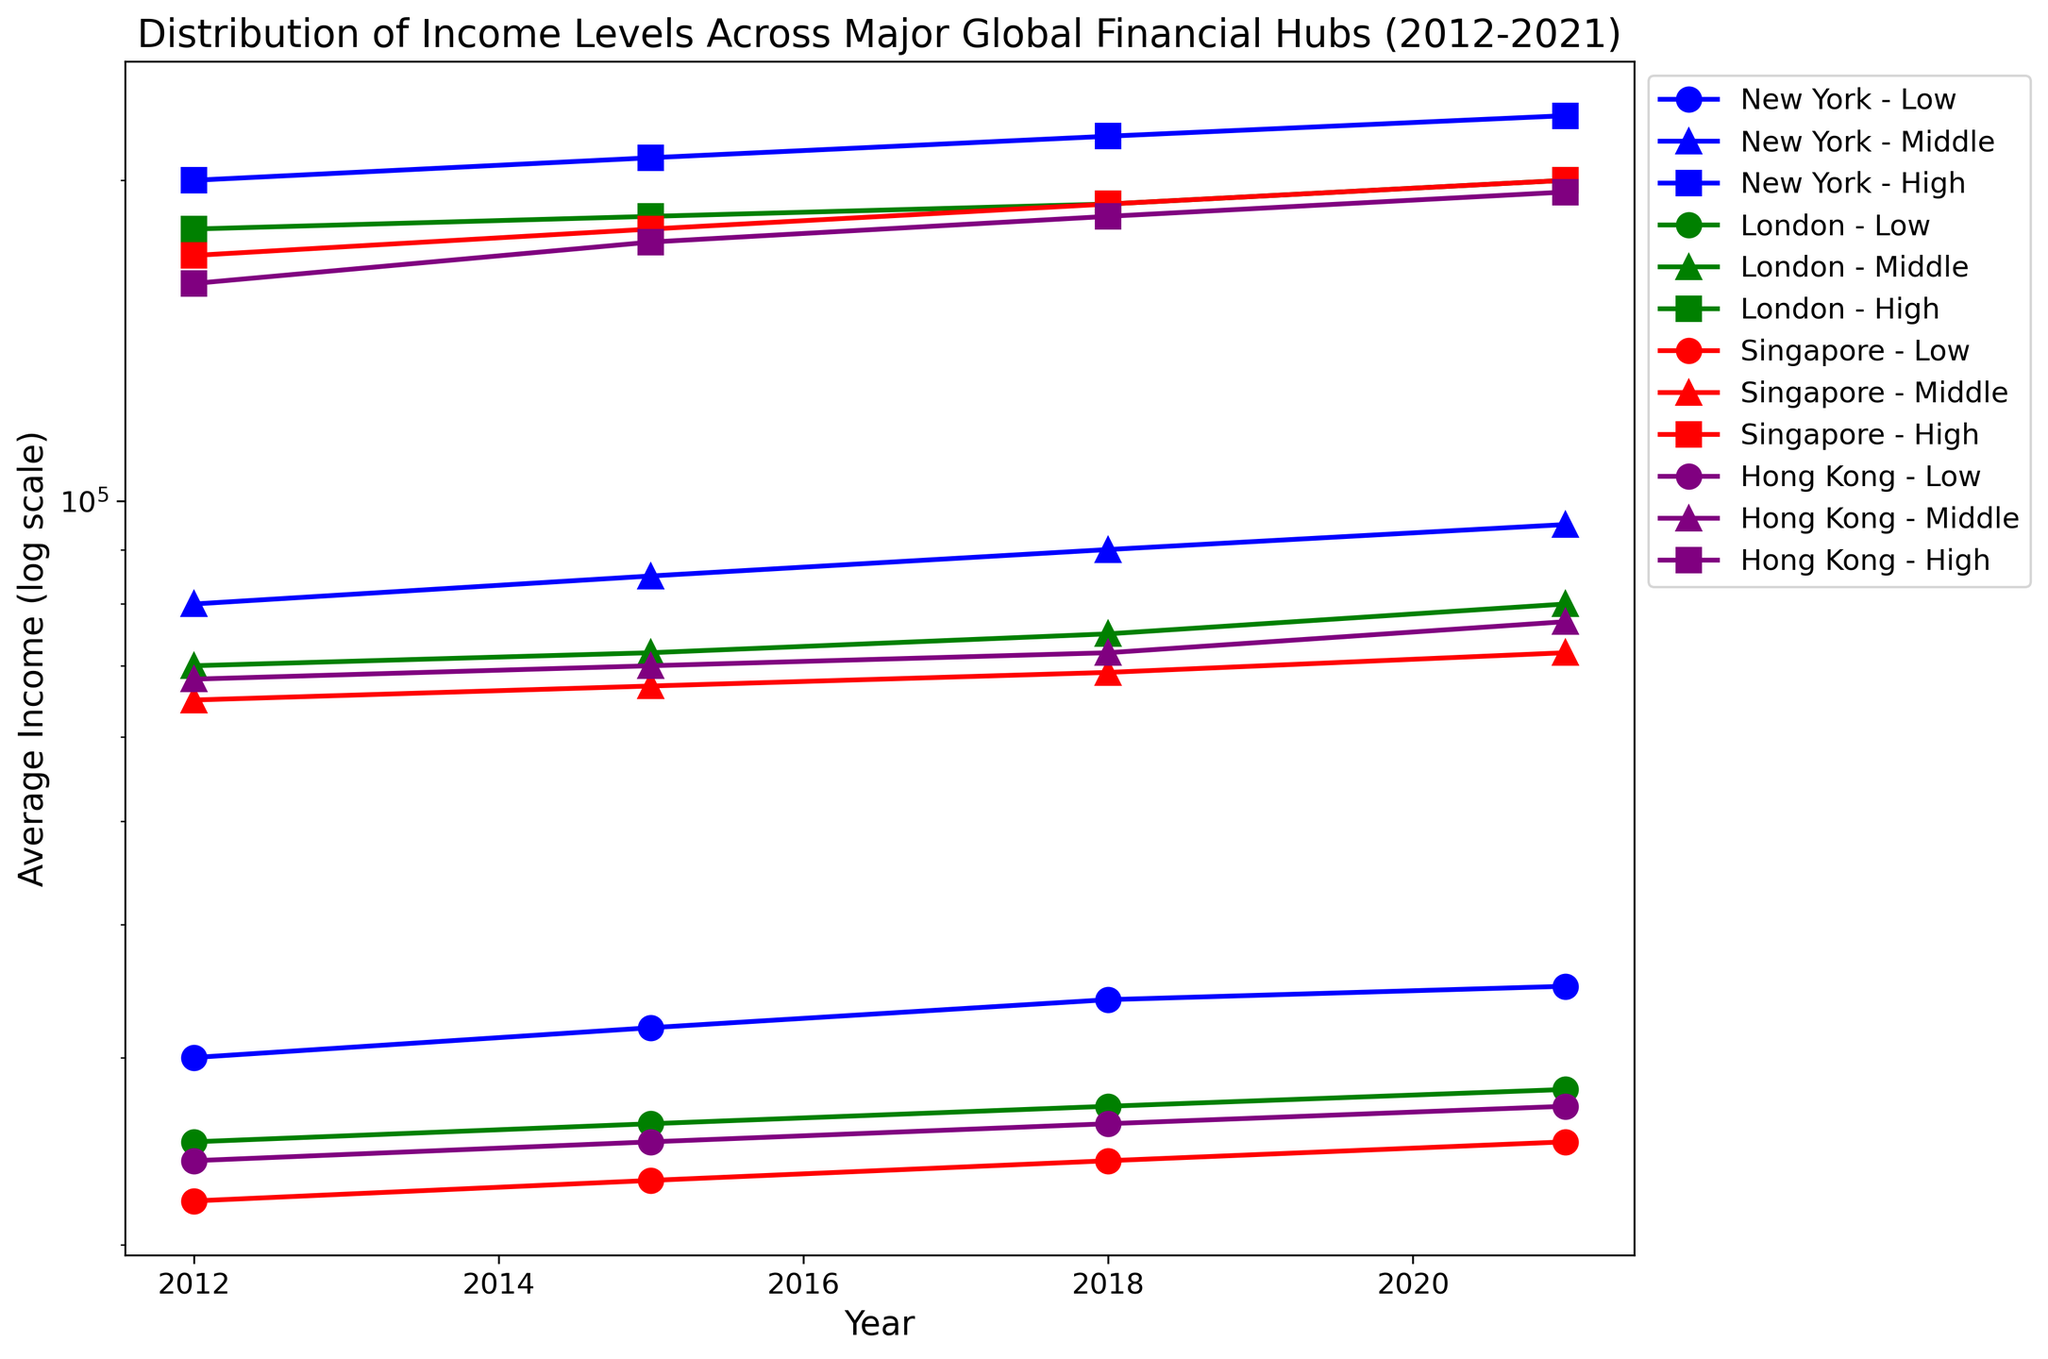What was the average income for the low-income level in London in 2021? To find the answer, identify the data point that corresponds to the location 'London', the income level 'Low', and the year '2021'. The figure shows the average income for this data point is 28,000.
Answer: 28,000 Which financial hub had the highest average income for the high-income level in 2021? To determine this, compare the average incomes for the high-income level across all financial hubs in the year 2021. From the figure, New York had the highest average income for the high-income level, which is 230,000.
Answer: New York How did the average income for the middle-income level in Singapore change from 2012 to 2021? Look at the data points for Singapore under the middle-income level for both years 2012 and 2021. In 2012, the average income was 65,000, and in 2021, it was 72,000. The change is calculated as 72,000 - 65,000.
Answer: Increased by 7,000 Between 2018 and 2021, which location saw the highest increase in average income for the low-income level? Examine the low-income level data points for all locations in 2018 and 2021, then calculate the increase. For each location: New York (35,000 - 34,000), London (28,000 - 27,000), Singapore (25,000 - 24,000), Hong Kong (27,000 - 26,000). New York saw the highest increase.
Answer: New York What is the overall trend for the high-income level in New York from 2012 to 2021? Observe the trend line for the high-income level in New York over the years 2012, 2015, 2018, and 2021. The income levels are 200,000, 210,000, 220,000, and 230,000, respectively. The trend shows a consistent increase in average income over the decade.
Answer: Increasing Compare the average income for the middle-income level in Hong Kong and London in 2015. Which location had a higher average income? Find the data points for the middle-income level for Hong Kong and London in 2015. Hong Kong had an average income of 70,000, while London had 72,000. Thus, London had a higher average income by 2,000.
Answer: London What was the difference in average income between the low and high-income levels in Singapore in 2012? Find the average income for the low-income level (22,000) and the high-income level (170,000) in Singapore for 2012. Then, calculate the difference: 170,000 - 22,000 = 148,000.
Answer: 148,000 Which income level saw the most significant increase in average income in Hong Kong from 2012 to 2021? Compare the changes in average income for low, middle, and high levels from 2012 to 2021 in Hong Kong. The changes are: Low (27,000 - 24,000 = 3,000), Middle (77,000 - 68,000 = 9,000), High (195,000 - 160,000 = 35,000). The high-income level saw the most significant increase.
Answer: High 